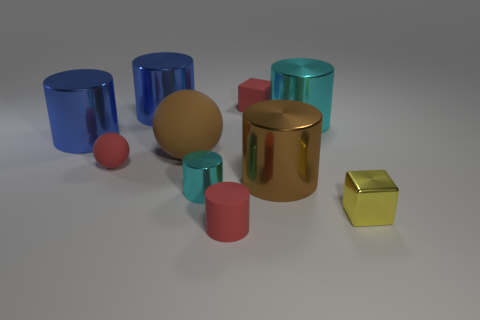Subtract all tiny red rubber cylinders. How many cylinders are left? 5 Subtract all blue cylinders. How many cylinders are left? 4 Subtract all blocks. How many objects are left? 8 Subtract 4 cylinders. How many cylinders are left? 2 Subtract all red cylinders. Subtract all brown balls. How many cylinders are left? 5 Subtract 0 gray cubes. How many objects are left? 10 Subtract all green blocks. How many yellow spheres are left? 0 Subtract all purple metal blocks. Subtract all blue objects. How many objects are left? 8 Add 1 tiny yellow things. How many tiny yellow things are left? 2 Add 4 small gray objects. How many small gray objects exist? 4 